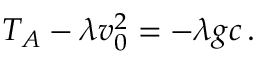<formula> <loc_0><loc_0><loc_500><loc_500>\begin{array} { r } { T _ { A } - \lambda v _ { 0 } ^ { 2 } = - \lambda g c \, . } \end{array}</formula> 